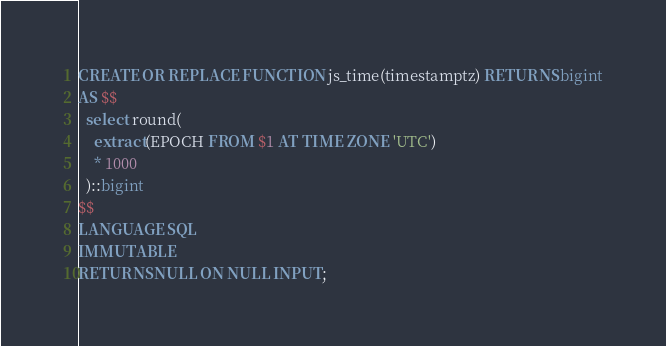<code> <loc_0><loc_0><loc_500><loc_500><_SQL_>CREATE OR REPLACE FUNCTION js_time(timestamptz) RETURNS bigint
AS $$
  select round(
    extract(EPOCH FROM $1 AT TIME ZONE 'UTC')
    * 1000
  )::bigint
$$ 
LANGUAGE SQL
IMMUTABLE
RETURNS NULL ON NULL INPUT;
</code> 